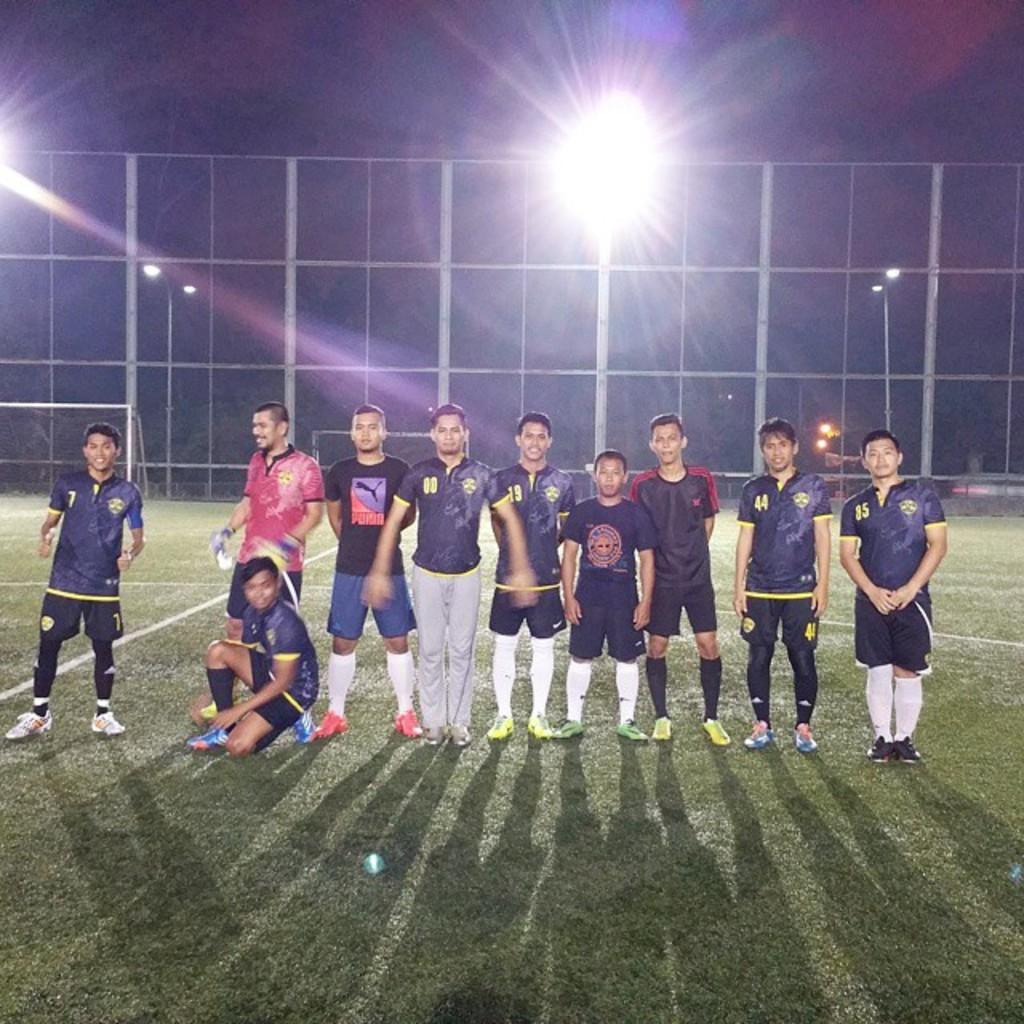What type of location is depicted in the image? There is a playground in the image. What are the men doing on the playground? The men are standing on the playground. Can you describe the interaction between the boy and one of the men? A boy is sitting on the knee of one of the men. What can be seen on the poles in the image? There are poles with lights visible in the image. What type of sign is the boy holding in the image? There is no sign present in the image; the boy is sitting on the knee of one of the men. 